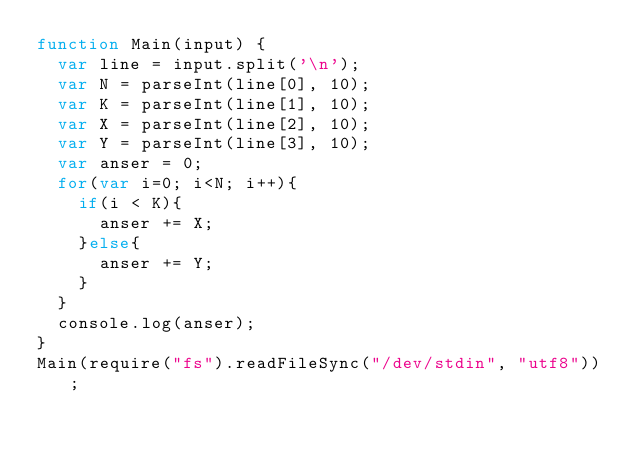<code> <loc_0><loc_0><loc_500><loc_500><_JavaScript_>function Main(input) {
	var line = input.split('\n');
	var N = parseInt(line[0], 10);
	var K = parseInt(line[1], 10);
	var X = parseInt(line[2], 10);
	var Y = parseInt(line[3], 10);
	var anser = 0;
	for(var i=0; i<N; i++){
		if(i < K){
			anser += X;
		}else{
			anser += Y;
		}
	}
	console.log(anser);
}
Main(require("fs").readFileSync("/dev/stdin", "utf8"));</code> 